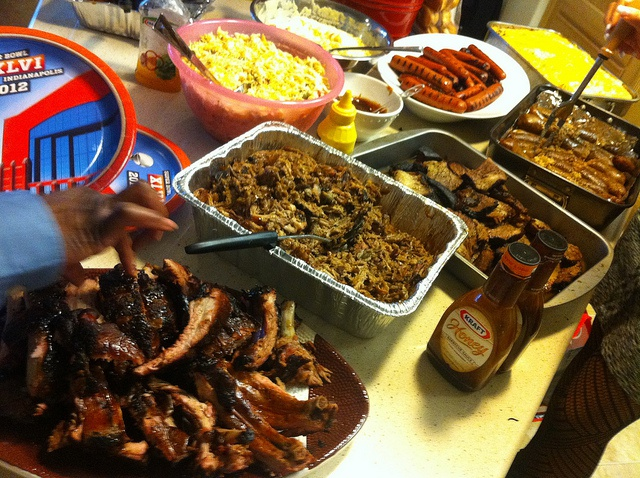Describe the objects in this image and their specific colors. I can see dining table in black, maroon, and olive tones, bowl in black, salmon, yellow, and khaki tones, people in black, maroon, and gray tones, bowl in black, ivory, brown, maroon, and red tones, and bottle in black, maroon, and olive tones in this image. 